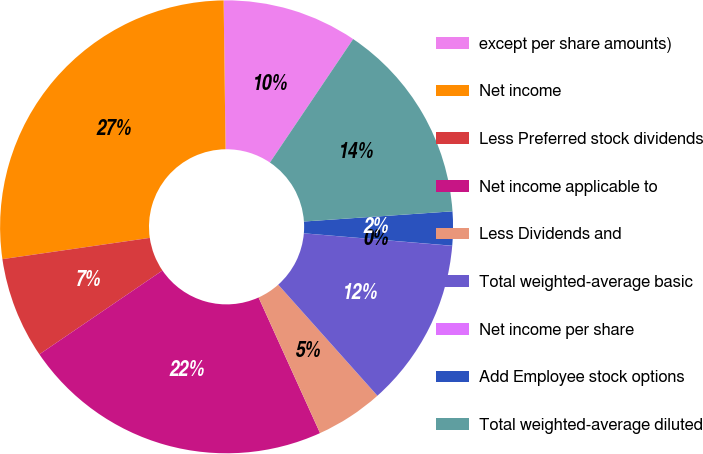Convert chart. <chart><loc_0><loc_0><loc_500><loc_500><pie_chart><fcel>except per share amounts)<fcel>Net income<fcel>Less Preferred stock dividends<fcel>Net income applicable to<fcel>Less Dividends and<fcel>Total weighted-average basic<fcel>Net income per share<fcel>Add Employee stock options<fcel>Total weighted-average diluted<nl><fcel>9.65%<fcel>27.08%<fcel>7.24%<fcel>22.26%<fcel>4.83%<fcel>12.06%<fcel>0.01%<fcel>2.42%<fcel>14.47%<nl></chart> 